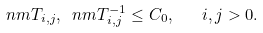Convert formula to latex. <formula><loc_0><loc_0><loc_500><loc_500>\ n m { T _ { i , j } } , \ n m { T _ { i , j } ^ { - 1 } } \leq C _ { 0 } , \quad i , j > 0 .</formula> 